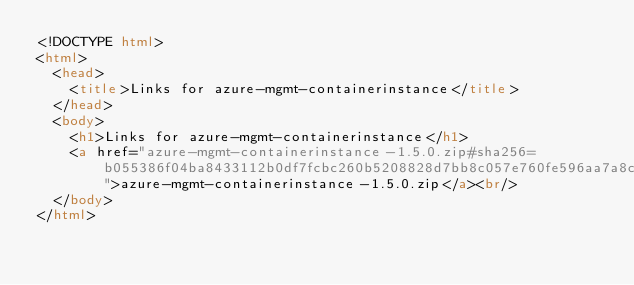Convert code to text. <code><loc_0><loc_0><loc_500><loc_500><_HTML_><!DOCTYPE html>
<html>
  <head>
    <title>Links for azure-mgmt-containerinstance</title>
  </head>
  <body>
    <h1>Links for azure-mgmt-containerinstance</h1>
    <a href="azure-mgmt-containerinstance-1.5.0.zip#sha256=b055386f04ba8433112b0df7fcbc260b5208828d7bb8c057e760fe596aa7a8cd">azure-mgmt-containerinstance-1.5.0.zip</a><br/>
  </body>
</html></code> 